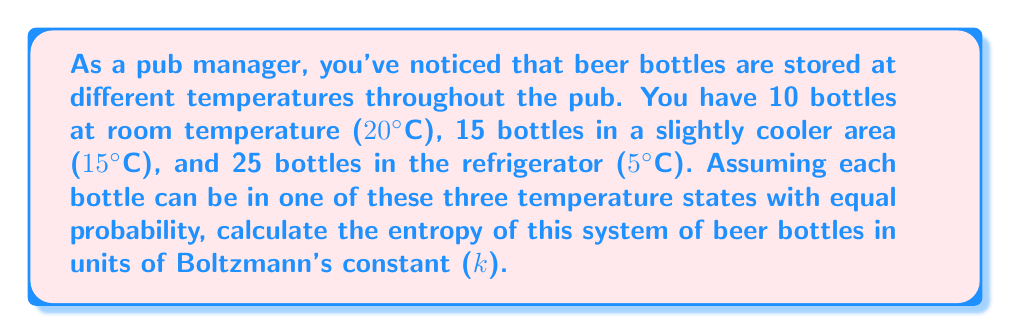Teach me how to tackle this problem. To calculate the entropy of this system, we'll use the formula for entropy in statistical mechanics:

$$S = -k \sum_{i} p_i \ln(p_i)$$

Where:
$S$ is the entropy
$k$ is Boltzmann's constant
$p_i$ is the probability of the system being in the i-th microstate

Step 1: Determine the total number of bottles and the probability of each state.
Total bottles: 10 + 15 + 25 = 50
Probability of each state: $p_1 = p_2 = p_3 = \frac{1}{3}$

Step 2: Apply the entropy formula:

$$\begin{align*}
S &= -k \left(p_1 \ln(p_1) + p_2 \ln(p_2) + p_3 \ln(p_3)\right) \\
&= -k \left(\frac{1}{3} \ln(\frac{1}{3}) + \frac{1}{3} \ln(\frac{1}{3}) + \frac{1}{3} \ln(\frac{1}{3})\right) \\
&= -k \left(3 \cdot \frac{1}{3} \ln(\frac{1}{3})\right) \\
&= -k \ln(\frac{1}{3}) \\
&= k \ln(3)
\end{align*}$$

Step 3: Express the result in terms of Boltzmann's constant.
The entropy of the system is $k \ln(3)$.
Answer: $k \ln(3)$ 